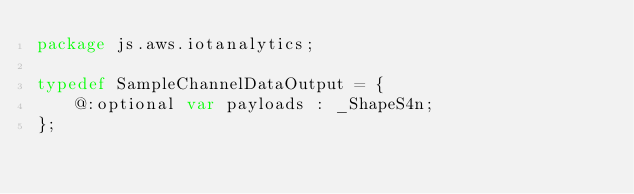<code> <loc_0><loc_0><loc_500><loc_500><_Haxe_>package js.aws.iotanalytics;

typedef SampleChannelDataOutput = {
    @:optional var payloads : _ShapeS4n;
};
</code> 